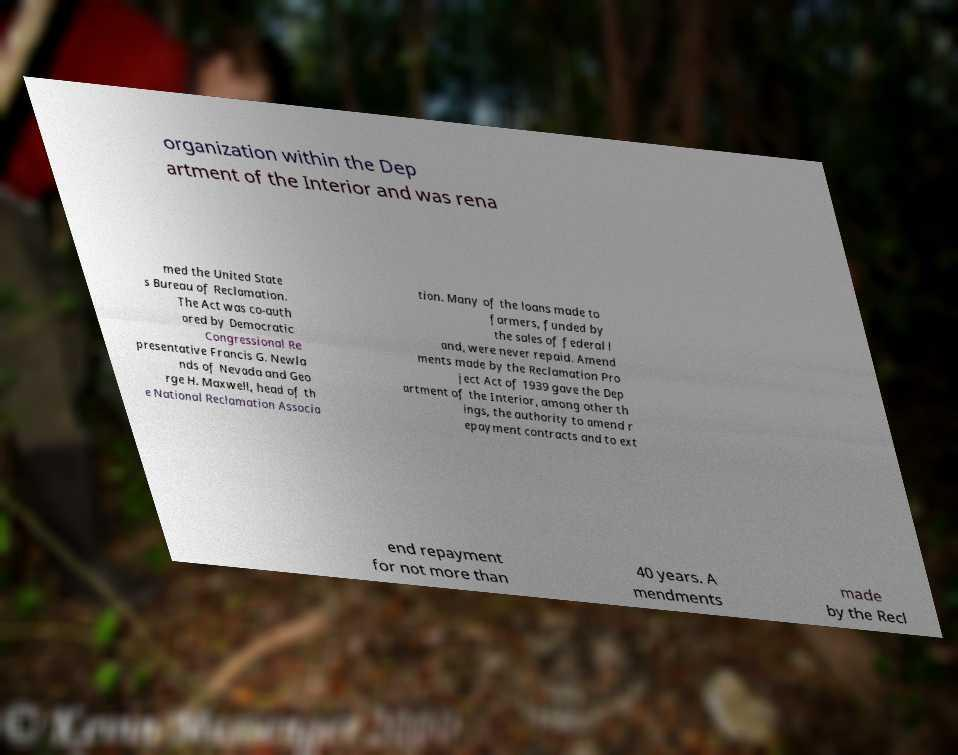There's text embedded in this image that I need extracted. Can you transcribe it verbatim? organization within the Dep artment of the Interior and was rena med the United State s Bureau of Reclamation. The Act was co-auth ored by Democratic Congressional Re presentative Francis G. Newla nds of Nevada and Geo rge H. Maxwell, head of th e National Reclamation Associa tion. Many of the loans made to farmers, funded by the sales of federal l and, were never repaid. Amend ments made by the Reclamation Pro ject Act of 1939 gave the Dep artment of the Interior, among other th ings, the authority to amend r epayment contracts and to ext end repayment for not more than 40 years. A mendments made by the Recl 